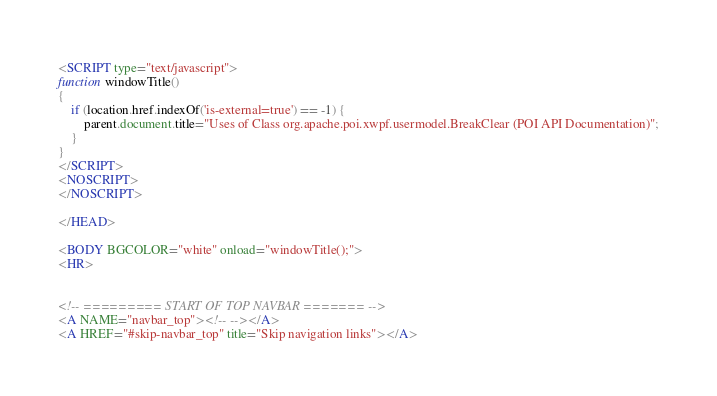Convert code to text. <code><loc_0><loc_0><loc_500><loc_500><_HTML_><SCRIPT type="text/javascript">
function windowTitle()
{
    if (location.href.indexOf('is-external=true') == -1) {
        parent.document.title="Uses of Class org.apache.poi.xwpf.usermodel.BreakClear (POI API Documentation)";
    }
}
</SCRIPT>
<NOSCRIPT>
</NOSCRIPT>

</HEAD>

<BODY BGCOLOR="white" onload="windowTitle();">
<HR>


<!-- ========= START OF TOP NAVBAR ======= -->
<A NAME="navbar_top"><!-- --></A>
<A HREF="#skip-navbar_top" title="Skip navigation links"></A></code> 